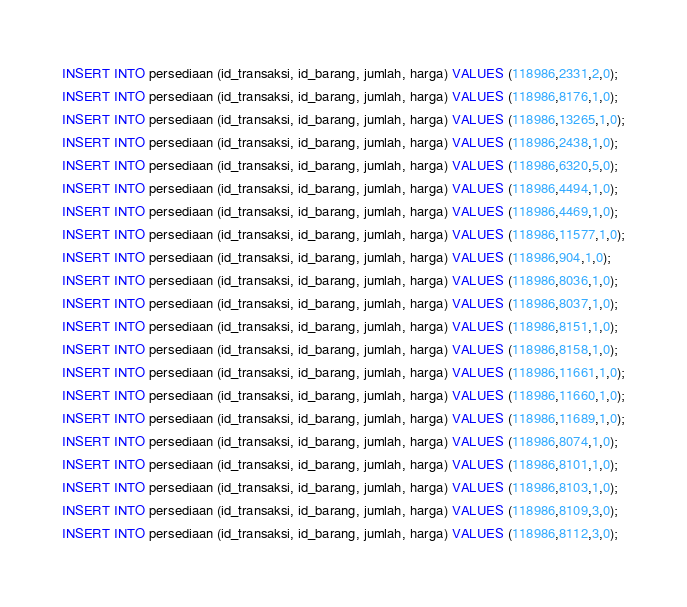Convert code to text. <code><loc_0><loc_0><loc_500><loc_500><_SQL_>INSERT INTO persediaan (id_transaksi, id_barang, jumlah, harga) VALUES (118986,2331,2,0);
INSERT INTO persediaan (id_transaksi, id_barang, jumlah, harga) VALUES (118986,8176,1,0);
INSERT INTO persediaan (id_transaksi, id_barang, jumlah, harga) VALUES (118986,13265,1,0);
INSERT INTO persediaan (id_transaksi, id_barang, jumlah, harga) VALUES (118986,2438,1,0);
INSERT INTO persediaan (id_transaksi, id_barang, jumlah, harga) VALUES (118986,6320,5,0);
INSERT INTO persediaan (id_transaksi, id_barang, jumlah, harga) VALUES (118986,4494,1,0);
INSERT INTO persediaan (id_transaksi, id_barang, jumlah, harga) VALUES (118986,4469,1,0);
INSERT INTO persediaan (id_transaksi, id_barang, jumlah, harga) VALUES (118986,11577,1,0);
INSERT INTO persediaan (id_transaksi, id_barang, jumlah, harga) VALUES (118986,904,1,0);
INSERT INTO persediaan (id_transaksi, id_barang, jumlah, harga) VALUES (118986,8036,1,0);
INSERT INTO persediaan (id_transaksi, id_barang, jumlah, harga) VALUES (118986,8037,1,0);
INSERT INTO persediaan (id_transaksi, id_barang, jumlah, harga) VALUES (118986,8151,1,0);
INSERT INTO persediaan (id_transaksi, id_barang, jumlah, harga) VALUES (118986,8158,1,0);
INSERT INTO persediaan (id_transaksi, id_barang, jumlah, harga) VALUES (118986,11661,1,0);
INSERT INTO persediaan (id_transaksi, id_barang, jumlah, harga) VALUES (118986,11660,1,0);
INSERT INTO persediaan (id_transaksi, id_barang, jumlah, harga) VALUES (118986,11689,1,0);
INSERT INTO persediaan (id_transaksi, id_barang, jumlah, harga) VALUES (118986,8074,1,0);
INSERT INTO persediaan (id_transaksi, id_barang, jumlah, harga) VALUES (118986,8101,1,0);
INSERT INTO persediaan (id_transaksi, id_barang, jumlah, harga) VALUES (118986,8103,1,0);
INSERT INTO persediaan (id_transaksi, id_barang, jumlah, harga) VALUES (118986,8109,3,0);
INSERT INTO persediaan (id_transaksi, id_barang, jumlah, harga) VALUES (118986,8112,3,0);
</code> 